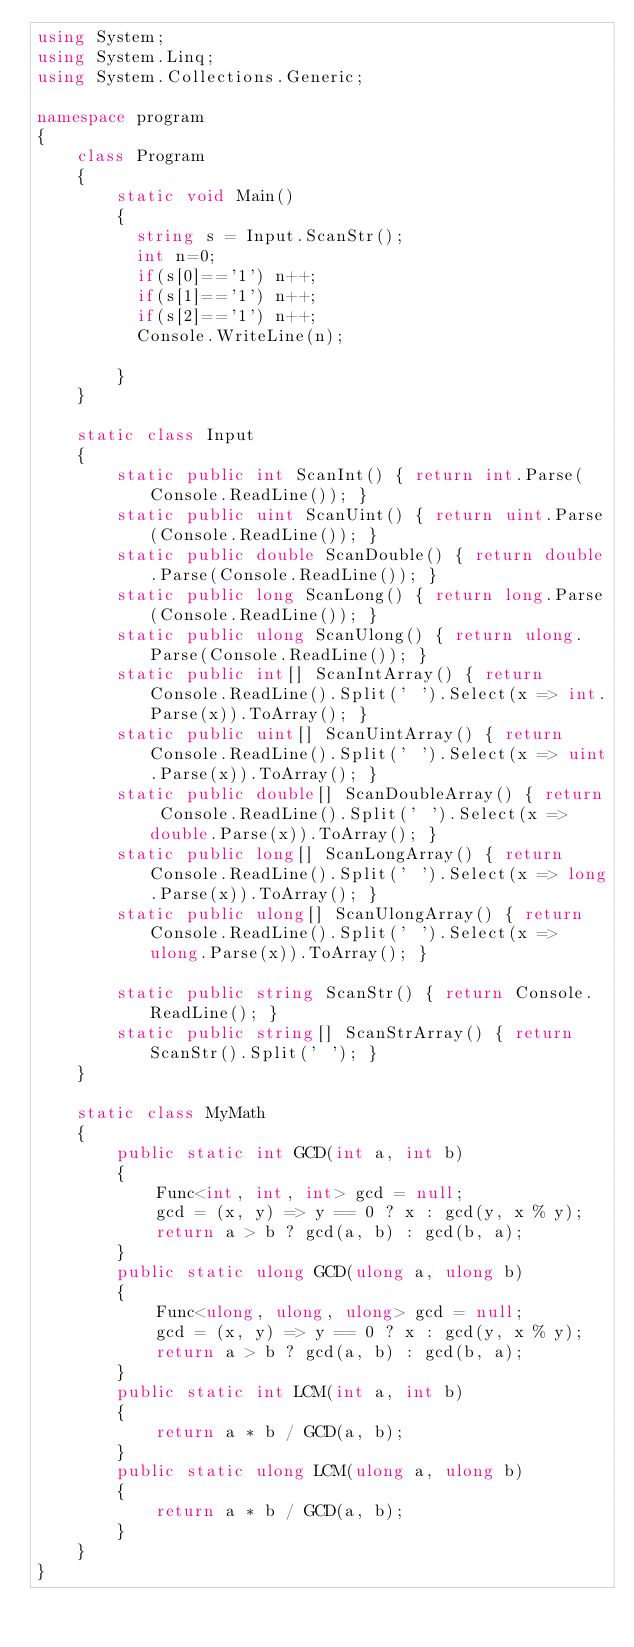<code> <loc_0><loc_0><loc_500><loc_500><_C#_>using System;
using System.Linq;
using System.Collections.Generic;

namespace program
{
    class Program
    {
        static void Main()
        {
          string s = Input.ScanStr();
          int n=0;
          if(s[0]=='1') n++;
          if(s[1]=='1') n++;
          if(s[2]=='1') n++;
          Console.WriteLine(n);
          
        }
    }

    static class Input
    {
        static public int ScanInt() { return int.Parse(Console.ReadLine()); }
        static public uint ScanUint() { return uint.Parse(Console.ReadLine()); }
        static public double ScanDouble() { return double.Parse(Console.ReadLine()); }
        static public long ScanLong() { return long.Parse(Console.ReadLine()); }
        static public ulong ScanUlong() { return ulong.Parse(Console.ReadLine()); }
        static public int[] ScanIntArray() { return Console.ReadLine().Split(' ').Select(x => int.Parse(x)).ToArray(); }
        static public uint[] ScanUintArray() { return Console.ReadLine().Split(' ').Select(x => uint.Parse(x)).ToArray(); }
        static public double[] ScanDoubleArray() { return Console.ReadLine().Split(' ').Select(x => double.Parse(x)).ToArray(); }
        static public long[] ScanLongArray() { return Console.ReadLine().Split(' ').Select(x => long.Parse(x)).ToArray(); }
        static public ulong[] ScanUlongArray() { return Console.ReadLine().Split(' ').Select(x => ulong.Parse(x)).ToArray(); }

        static public string ScanStr() { return Console.ReadLine(); }
        static public string[] ScanStrArray() { return ScanStr().Split(' '); }
    }

    static class MyMath
    {
        public static int GCD(int a, int b)
        {
            Func<int, int, int> gcd = null;
            gcd = (x, y) => y == 0 ? x : gcd(y, x % y);
            return a > b ? gcd(a, b) : gcd(b, a);
        }
        public static ulong GCD(ulong a, ulong b)
        {
            Func<ulong, ulong, ulong> gcd = null;
            gcd = (x, y) => y == 0 ? x : gcd(y, x % y);
            return a > b ? gcd(a, b) : gcd(b, a);
        }
        public static int LCM(int a, int b)
        {
            return a * b / GCD(a, b);
        }
        public static ulong LCM(ulong a, ulong b)
        {
            return a * b / GCD(a, b);
        }
    }
}
</code> 